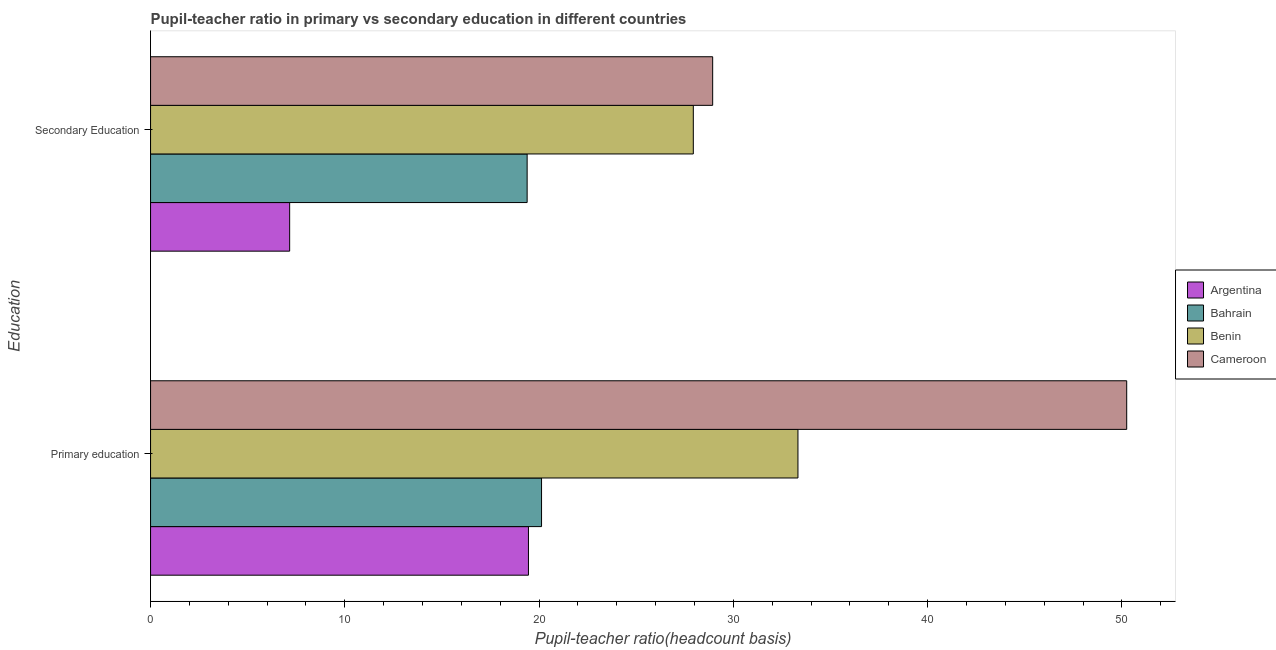How many different coloured bars are there?
Your answer should be compact. 4. What is the label of the 1st group of bars from the top?
Offer a terse response. Secondary Education. What is the pupil-teacher ratio in primary education in Argentina?
Give a very brief answer. 19.45. Across all countries, what is the maximum pupil teacher ratio on secondary education?
Give a very brief answer. 28.94. Across all countries, what is the minimum pupil teacher ratio on secondary education?
Give a very brief answer. 7.16. In which country was the pupil teacher ratio on secondary education maximum?
Give a very brief answer. Cameroon. In which country was the pupil-teacher ratio in primary education minimum?
Ensure brevity in your answer.  Argentina. What is the total pupil-teacher ratio in primary education in the graph?
Your answer should be compact. 123.15. What is the difference between the pupil teacher ratio on secondary education in Bahrain and that in Benin?
Ensure brevity in your answer.  -8.55. What is the difference between the pupil-teacher ratio in primary education in Argentina and the pupil teacher ratio on secondary education in Bahrain?
Keep it short and to the point. 0.07. What is the average pupil-teacher ratio in primary education per country?
Offer a very short reply. 30.79. What is the difference between the pupil-teacher ratio in primary education and pupil teacher ratio on secondary education in Argentina?
Offer a terse response. 12.29. What is the ratio of the pupil-teacher ratio in primary education in Benin to that in Bahrain?
Give a very brief answer. 1.66. What does the 2nd bar from the top in Primary education represents?
Your answer should be very brief. Benin. What does the 2nd bar from the bottom in Secondary Education represents?
Offer a very short reply. Bahrain. How many bars are there?
Make the answer very short. 8. How many countries are there in the graph?
Your answer should be very brief. 4. What is the difference between two consecutive major ticks on the X-axis?
Provide a short and direct response. 10. How many legend labels are there?
Keep it short and to the point. 4. What is the title of the graph?
Give a very brief answer. Pupil-teacher ratio in primary vs secondary education in different countries. Does "Montenegro" appear as one of the legend labels in the graph?
Your response must be concise. No. What is the label or title of the X-axis?
Provide a short and direct response. Pupil-teacher ratio(headcount basis). What is the label or title of the Y-axis?
Make the answer very short. Education. What is the Pupil-teacher ratio(headcount basis) of Argentina in Primary education?
Your response must be concise. 19.45. What is the Pupil-teacher ratio(headcount basis) in Bahrain in Primary education?
Provide a short and direct response. 20.13. What is the Pupil-teacher ratio(headcount basis) in Benin in Primary education?
Offer a terse response. 33.33. What is the Pupil-teacher ratio(headcount basis) of Cameroon in Primary education?
Provide a short and direct response. 50.25. What is the Pupil-teacher ratio(headcount basis) of Argentina in Secondary Education?
Provide a short and direct response. 7.16. What is the Pupil-teacher ratio(headcount basis) of Bahrain in Secondary Education?
Keep it short and to the point. 19.38. What is the Pupil-teacher ratio(headcount basis) in Benin in Secondary Education?
Make the answer very short. 27.94. What is the Pupil-teacher ratio(headcount basis) in Cameroon in Secondary Education?
Give a very brief answer. 28.94. Across all Education, what is the maximum Pupil-teacher ratio(headcount basis) of Argentina?
Make the answer very short. 19.45. Across all Education, what is the maximum Pupil-teacher ratio(headcount basis) of Bahrain?
Provide a short and direct response. 20.13. Across all Education, what is the maximum Pupil-teacher ratio(headcount basis) of Benin?
Keep it short and to the point. 33.33. Across all Education, what is the maximum Pupil-teacher ratio(headcount basis) in Cameroon?
Ensure brevity in your answer.  50.25. Across all Education, what is the minimum Pupil-teacher ratio(headcount basis) in Argentina?
Ensure brevity in your answer.  7.16. Across all Education, what is the minimum Pupil-teacher ratio(headcount basis) in Bahrain?
Your answer should be compact. 19.38. Across all Education, what is the minimum Pupil-teacher ratio(headcount basis) in Benin?
Provide a succinct answer. 27.94. Across all Education, what is the minimum Pupil-teacher ratio(headcount basis) in Cameroon?
Your answer should be compact. 28.94. What is the total Pupil-teacher ratio(headcount basis) of Argentina in the graph?
Your answer should be compact. 26.61. What is the total Pupil-teacher ratio(headcount basis) of Bahrain in the graph?
Your answer should be very brief. 39.51. What is the total Pupil-teacher ratio(headcount basis) in Benin in the graph?
Make the answer very short. 61.26. What is the total Pupil-teacher ratio(headcount basis) of Cameroon in the graph?
Give a very brief answer. 79.18. What is the difference between the Pupil-teacher ratio(headcount basis) of Argentina in Primary education and that in Secondary Education?
Make the answer very short. 12.29. What is the difference between the Pupil-teacher ratio(headcount basis) in Bahrain in Primary education and that in Secondary Education?
Make the answer very short. 0.74. What is the difference between the Pupil-teacher ratio(headcount basis) of Benin in Primary education and that in Secondary Education?
Offer a terse response. 5.39. What is the difference between the Pupil-teacher ratio(headcount basis) of Cameroon in Primary education and that in Secondary Education?
Ensure brevity in your answer.  21.31. What is the difference between the Pupil-teacher ratio(headcount basis) in Argentina in Primary education and the Pupil-teacher ratio(headcount basis) in Bahrain in Secondary Education?
Your answer should be very brief. 0.07. What is the difference between the Pupil-teacher ratio(headcount basis) in Argentina in Primary education and the Pupil-teacher ratio(headcount basis) in Benin in Secondary Education?
Make the answer very short. -8.49. What is the difference between the Pupil-teacher ratio(headcount basis) in Argentina in Primary education and the Pupil-teacher ratio(headcount basis) in Cameroon in Secondary Education?
Make the answer very short. -9.48. What is the difference between the Pupil-teacher ratio(headcount basis) in Bahrain in Primary education and the Pupil-teacher ratio(headcount basis) in Benin in Secondary Education?
Provide a succinct answer. -7.81. What is the difference between the Pupil-teacher ratio(headcount basis) of Bahrain in Primary education and the Pupil-teacher ratio(headcount basis) of Cameroon in Secondary Education?
Offer a terse response. -8.81. What is the difference between the Pupil-teacher ratio(headcount basis) of Benin in Primary education and the Pupil-teacher ratio(headcount basis) of Cameroon in Secondary Education?
Your response must be concise. 4.39. What is the average Pupil-teacher ratio(headcount basis) of Argentina per Education?
Offer a very short reply. 13.31. What is the average Pupil-teacher ratio(headcount basis) in Bahrain per Education?
Your answer should be very brief. 19.76. What is the average Pupil-teacher ratio(headcount basis) of Benin per Education?
Give a very brief answer. 30.63. What is the average Pupil-teacher ratio(headcount basis) of Cameroon per Education?
Your answer should be very brief. 39.59. What is the difference between the Pupil-teacher ratio(headcount basis) of Argentina and Pupil-teacher ratio(headcount basis) of Bahrain in Primary education?
Offer a very short reply. -0.67. What is the difference between the Pupil-teacher ratio(headcount basis) in Argentina and Pupil-teacher ratio(headcount basis) in Benin in Primary education?
Your answer should be compact. -13.87. What is the difference between the Pupil-teacher ratio(headcount basis) in Argentina and Pupil-teacher ratio(headcount basis) in Cameroon in Primary education?
Provide a succinct answer. -30.8. What is the difference between the Pupil-teacher ratio(headcount basis) in Bahrain and Pupil-teacher ratio(headcount basis) in Benin in Primary education?
Offer a terse response. -13.2. What is the difference between the Pupil-teacher ratio(headcount basis) of Bahrain and Pupil-teacher ratio(headcount basis) of Cameroon in Primary education?
Provide a short and direct response. -30.12. What is the difference between the Pupil-teacher ratio(headcount basis) in Benin and Pupil-teacher ratio(headcount basis) in Cameroon in Primary education?
Keep it short and to the point. -16.92. What is the difference between the Pupil-teacher ratio(headcount basis) of Argentina and Pupil-teacher ratio(headcount basis) of Bahrain in Secondary Education?
Provide a succinct answer. -12.22. What is the difference between the Pupil-teacher ratio(headcount basis) of Argentina and Pupil-teacher ratio(headcount basis) of Benin in Secondary Education?
Make the answer very short. -20.78. What is the difference between the Pupil-teacher ratio(headcount basis) in Argentina and Pupil-teacher ratio(headcount basis) in Cameroon in Secondary Education?
Your response must be concise. -21.78. What is the difference between the Pupil-teacher ratio(headcount basis) in Bahrain and Pupil-teacher ratio(headcount basis) in Benin in Secondary Education?
Ensure brevity in your answer.  -8.55. What is the difference between the Pupil-teacher ratio(headcount basis) in Bahrain and Pupil-teacher ratio(headcount basis) in Cameroon in Secondary Education?
Make the answer very short. -9.55. What is the difference between the Pupil-teacher ratio(headcount basis) in Benin and Pupil-teacher ratio(headcount basis) in Cameroon in Secondary Education?
Ensure brevity in your answer.  -1. What is the ratio of the Pupil-teacher ratio(headcount basis) of Argentina in Primary education to that in Secondary Education?
Make the answer very short. 2.72. What is the ratio of the Pupil-teacher ratio(headcount basis) of Bahrain in Primary education to that in Secondary Education?
Offer a terse response. 1.04. What is the ratio of the Pupil-teacher ratio(headcount basis) of Benin in Primary education to that in Secondary Education?
Ensure brevity in your answer.  1.19. What is the ratio of the Pupil-teacher ratio(headcount basis) of Cameroon in Primary education to that in Secondary Education?
Keep it short and to the point. 1.74. What is the difference between the highest and the second highest Pupil-teacher ratio(headcount basis) in Argentina?
Your answer should be compact. 12.29. What is the difference between the highest and the second highest Pupil-teacher ratio(headcount basis) of Bahrain?
Your answer should be very brief. 0.74. What is the difference between the highest and the second highest Pupil-teacher ratio(headcount basis) of Benin?
Your response must be concise. 5.39. What is the difference between the highest and the second highest Pupil-teacher ratio(headcount basis) of Cameroon?
Your response must be concise. 21.31. What is the difference between the highest and the lowest Pupil-teacher ratio(headcount basis) in Argentina?
Provide a succinct answer. 12.29. What is the difference between the highest and the lowest Pupil-teacher ratio(headcount basis) of Bahrain?
Keep it short and to the point. 0.74. What is the difference between the highest and the lowest Pupil-teacher ratio(headcount basis) of Benin?
Provide a succinct answer. 5.39. What is the difference between the highest and the lowest Pupil-teacher ratio(headcount basis) of Cameroon?
Keep it short and to the point. 21.31. 